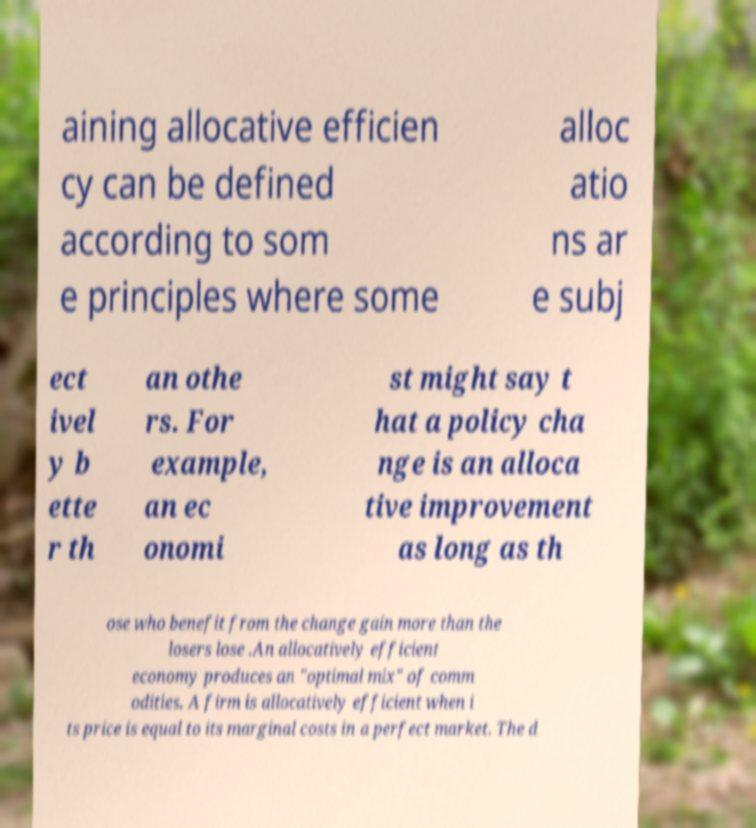I need the written content from this picture converted into text. Can you do that? aining allocative efficien cy can be defined according to som e principles where some alloc atio ns ar e subj ect ivel y b ette r th an othe rs. For example, an ec onomi st might say t hat a policy cha nge is an alloca tive improvement as long as th ose who benefit from the change gain more than the losers lose .An allocatively efficient economy produces an "optimal mix" of comm odities. A firm is allocatively efficient when i ts price is equal to its marginal costs in a perfect market. The d 